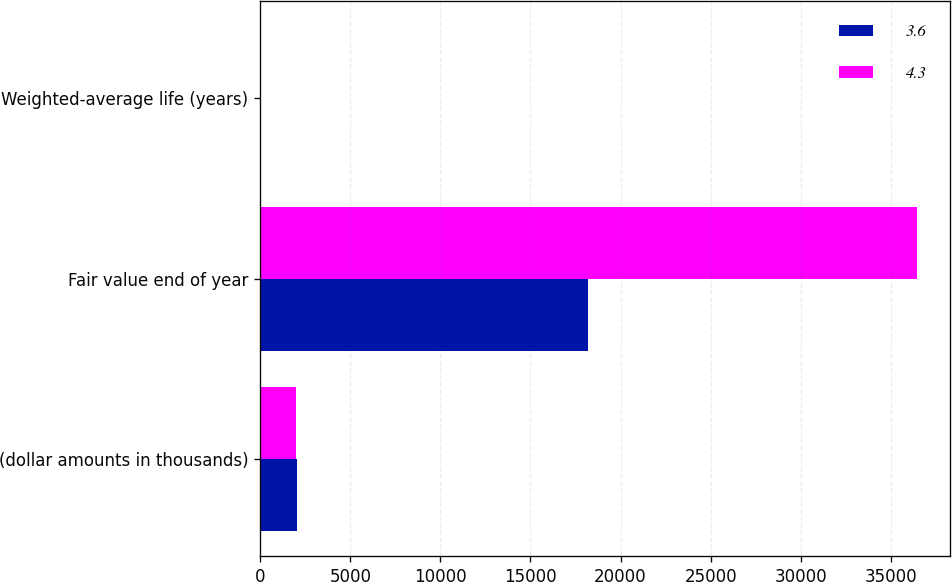Convert chart. <chart><loc_0><loc_0><loc_500><loc_500><stacked_bar_chart><ecel><fcel>(dollar amounts in thousands)<fcel>Fair value end of year<fcel>Weighted-average life (years)<nl><fcel>3.6<fcel>2013<fcel>18193<fcel>3.6<nl><fcel>4.3<fcel>2012<fcel>36470<fcel>4.3<nl></chart> 